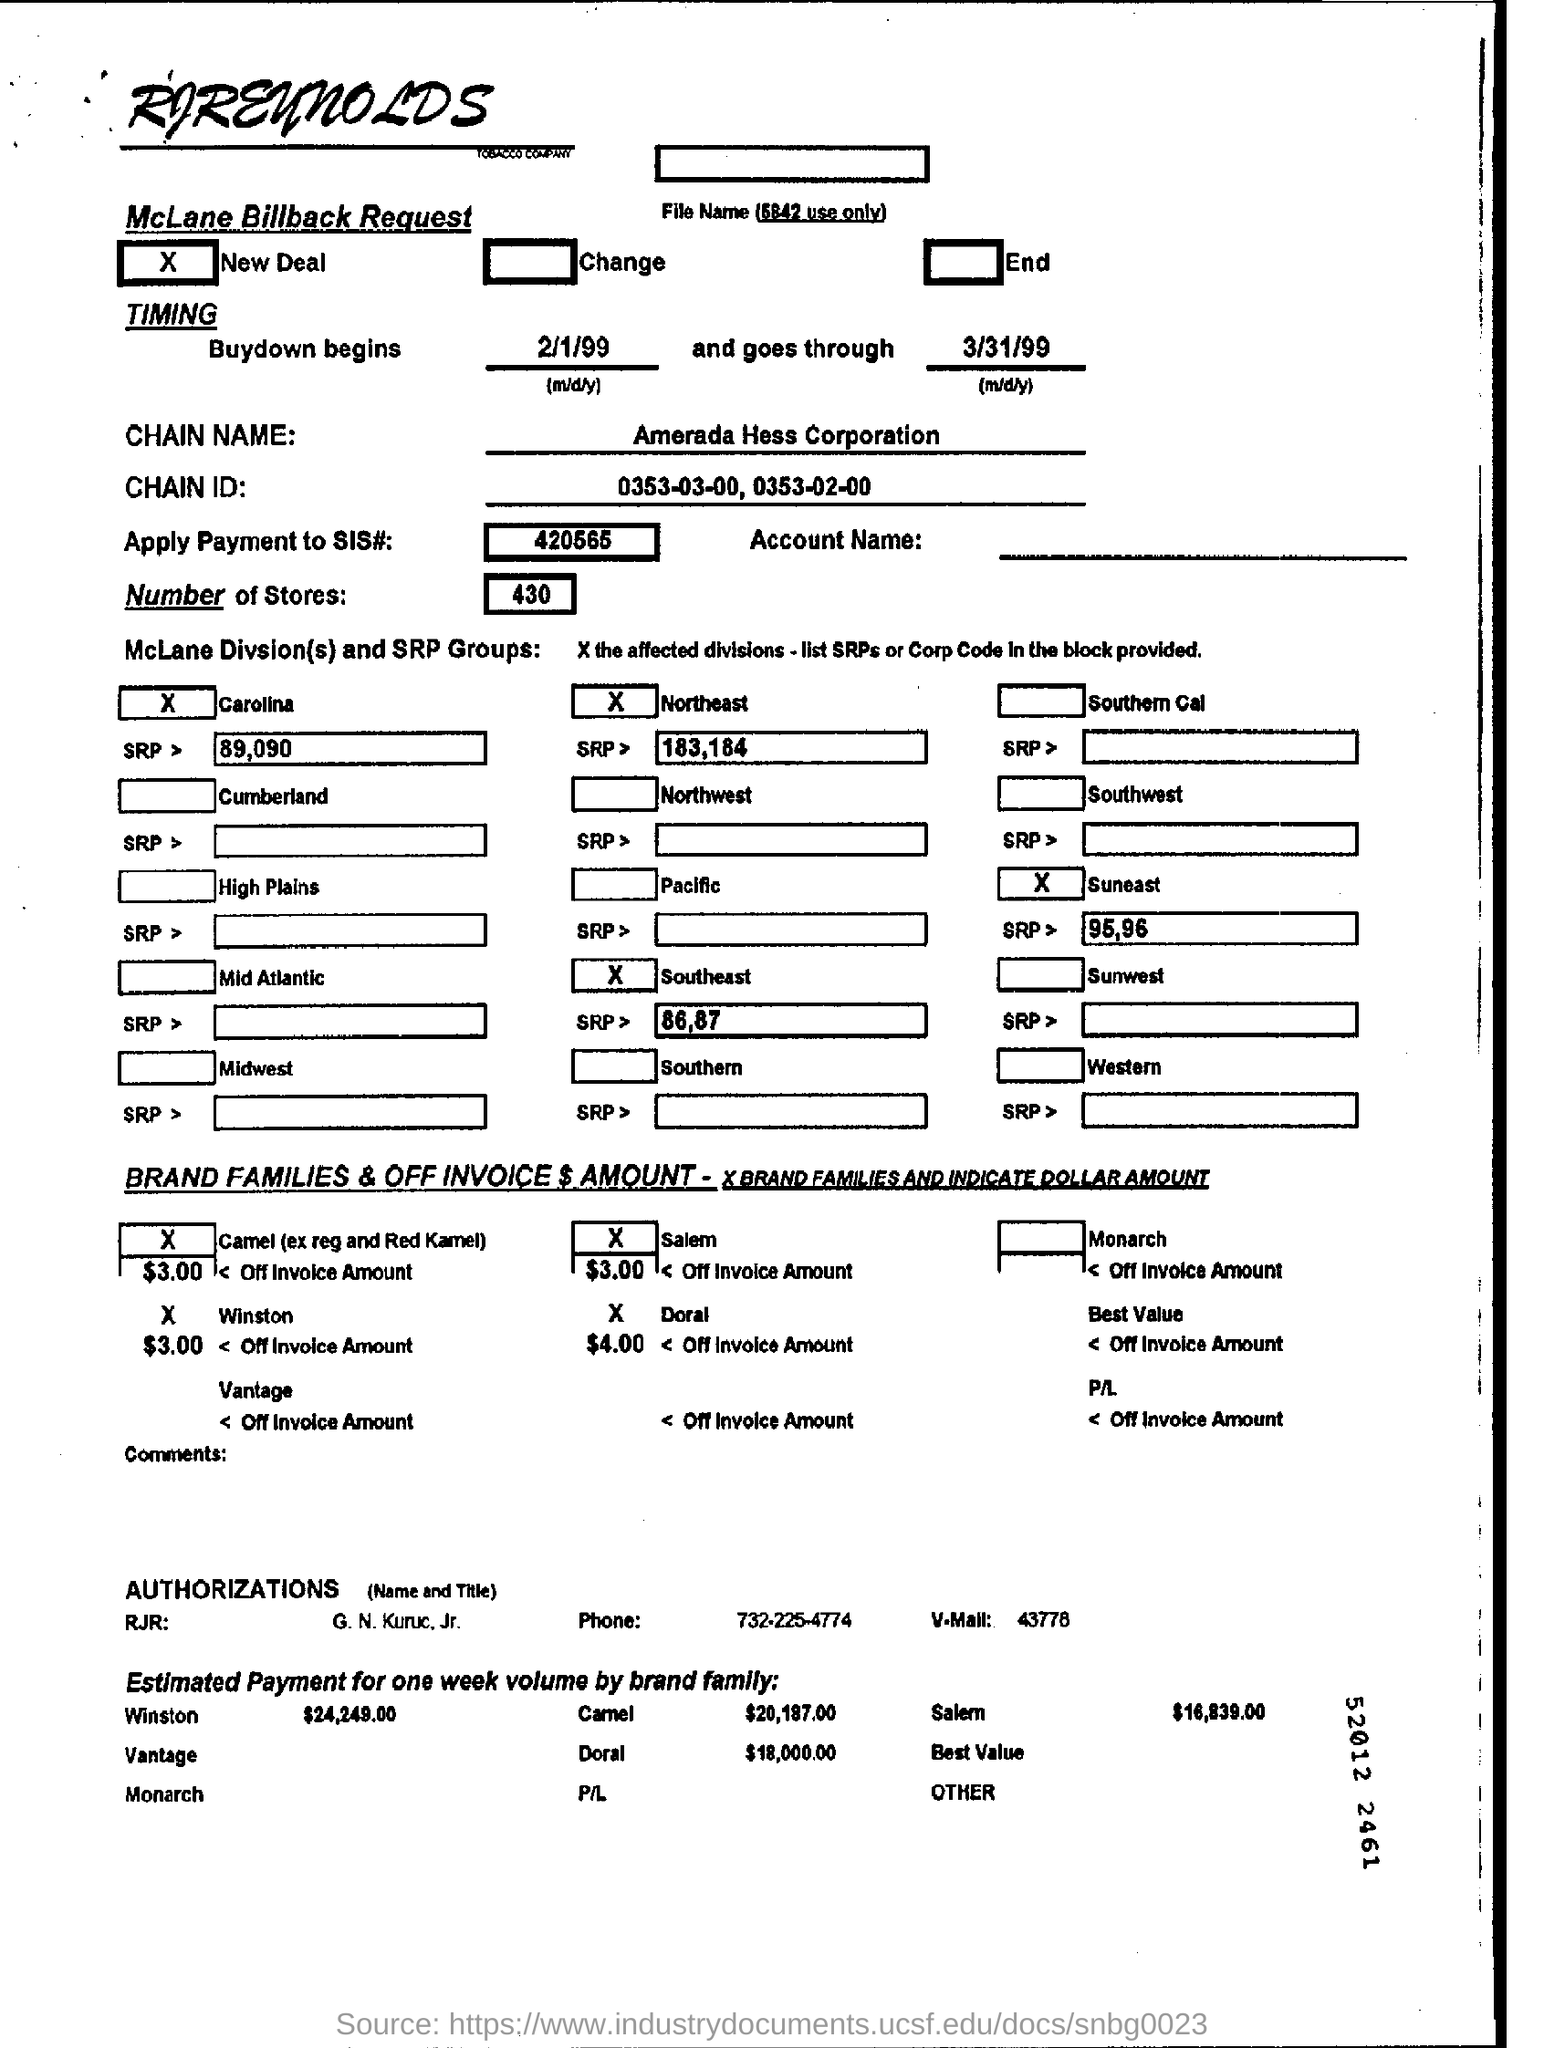What is the chain id?
Make the answer very short. 0353-03-00, 0353-02-00. What is the chain name?
Give a very brief answer. Amerada Hess Corporation. How many number of stores?
Provide a succinct answer. 430. 